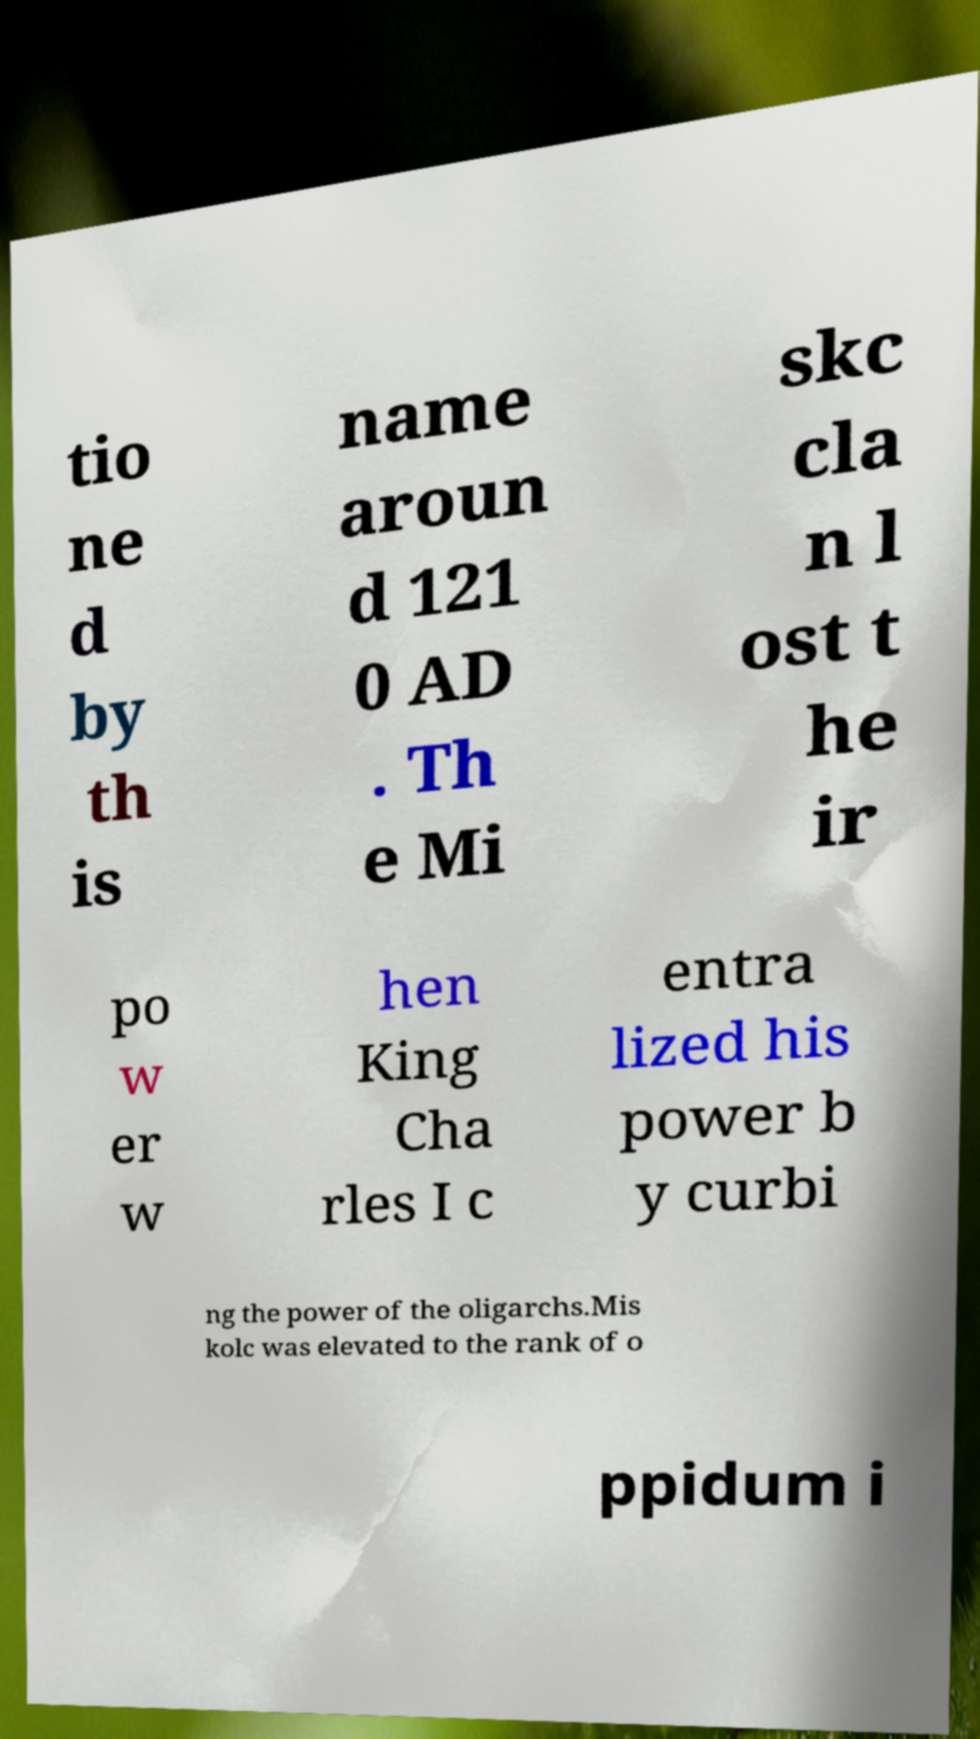Could you extract and type out the text from this image? tio ne d by th is name aroun d 121 0 AD . Th e Mi skc cla n l ost t he ir po w er w hen King Cha rles I c entra lized his power b y curbi ng the power of the oligarchs.Mis kolc was elevated to the rank of o ppidum i 